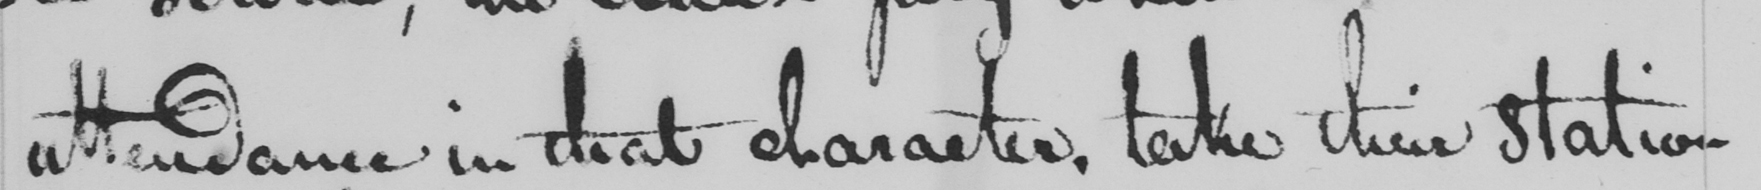What does this handwritten line say? attendance in that character , take their station 